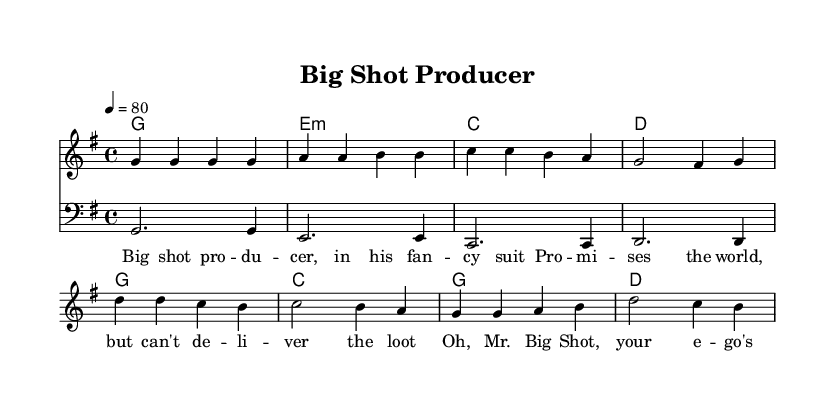What is the key signature of this music? The key signature is G major, which has one sharp (F#). This can be identified from the global settings where it states "\key g \major".
Answer: G major What is the time signature of this music? The time signature is 4/4, which indicates four beats per measure. This is found in the global settings with "\time 4/4".
Answer: 4/4 What is the tempo marking in this music? The tempo marking is 80 beats per minute, which is indicated by the tempo instruction "\tempo 4 = 80".
Answer: 80 What chord follows the D chord in the chorus? The chord that follows the D chord in the chorus is a G chord. This can be determined by looking at the chordNames section in the code and finding the order of chords.
Answer: G What is the primary theme of the lyrics? The primary theme of the lyrics revolves around criticizing a superficial entertainment industry figure, as indicated by phrases like "Mr. Big Shot" and "your shows are all hype".
Answer: Criticism of entertainment industry stereotypes How is the bass line structured in relation to the melody? The bass line provides a foundational support that emphasizes the root notes of the chords played in the melody, complementing the harmonic structure. This is interpreted from the bassLine section which follows the chord progression.
Answer: Root support 